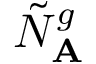<formula> <loc_0><loc_0><loc_500><loc_500>\tilde { N } _ { A } ^ { g }</formula> 